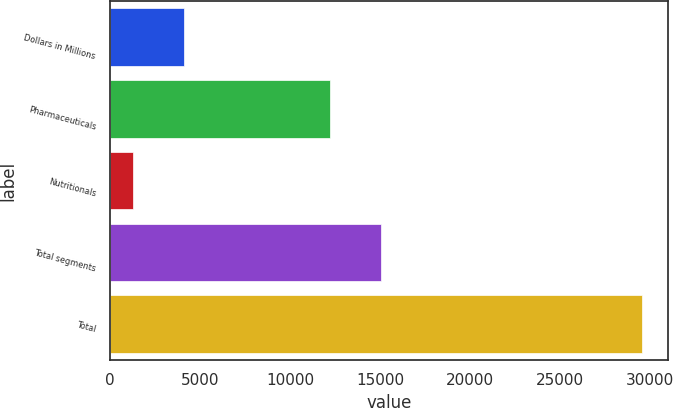Convert chart. <chart><loc_0><loc_0><loc_500><loc_500><bar_chart><fcel>Dollars in Millions<fcel>Pharmaceuticals<fcel>Nutritionals<fcel>Total segments<fcel>Total<nl><fcel>4104.5<fcel>12246<fcel>1277<fcel>15073.5<fcel>29552<nl></chart> 